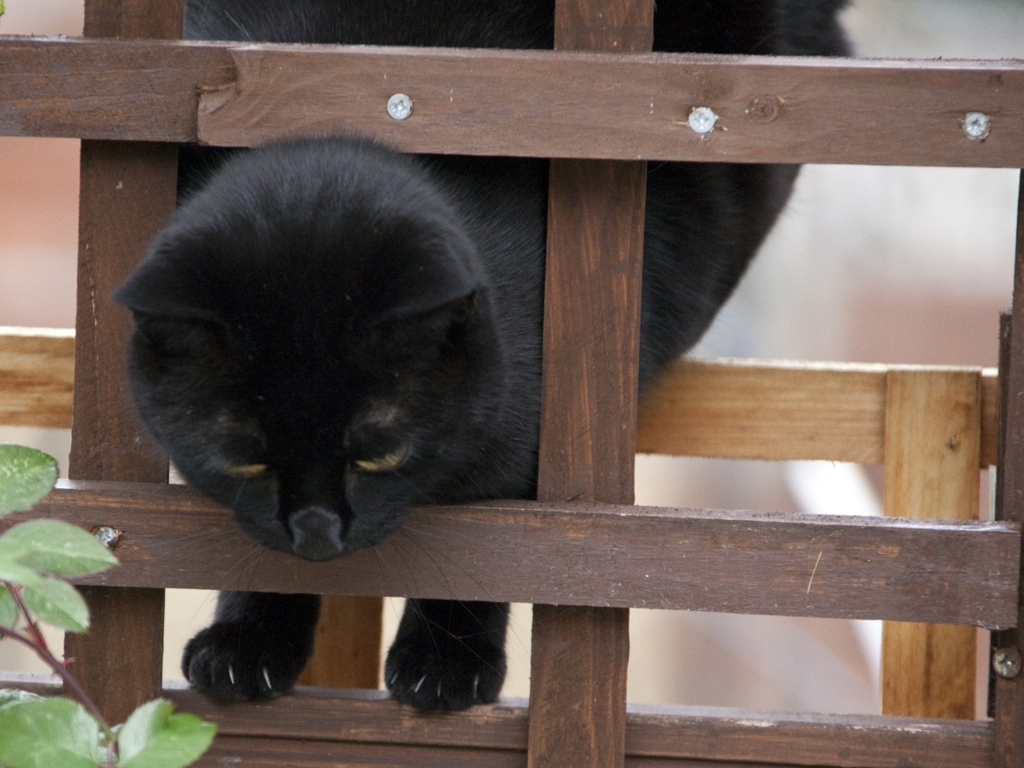What mood does the image convey? The image conveys a mood of quiet curiosity and contemplation. The black cat peeking through the wooden lattice suggests a sense of inquisitiveness, while also providing a serene and somewhat mysterious atmosphere. Can you describe the setting and how it complements the subject? The setting appears to be an outdoor area with the presence of a lattice and green foliage. It complements the subject by creating a natural frame around the cat, making it the focal point of the composition. The wooden texture and green leaves offer a contrast to the cat's sleek black fur, enhancing the visual appeal. 